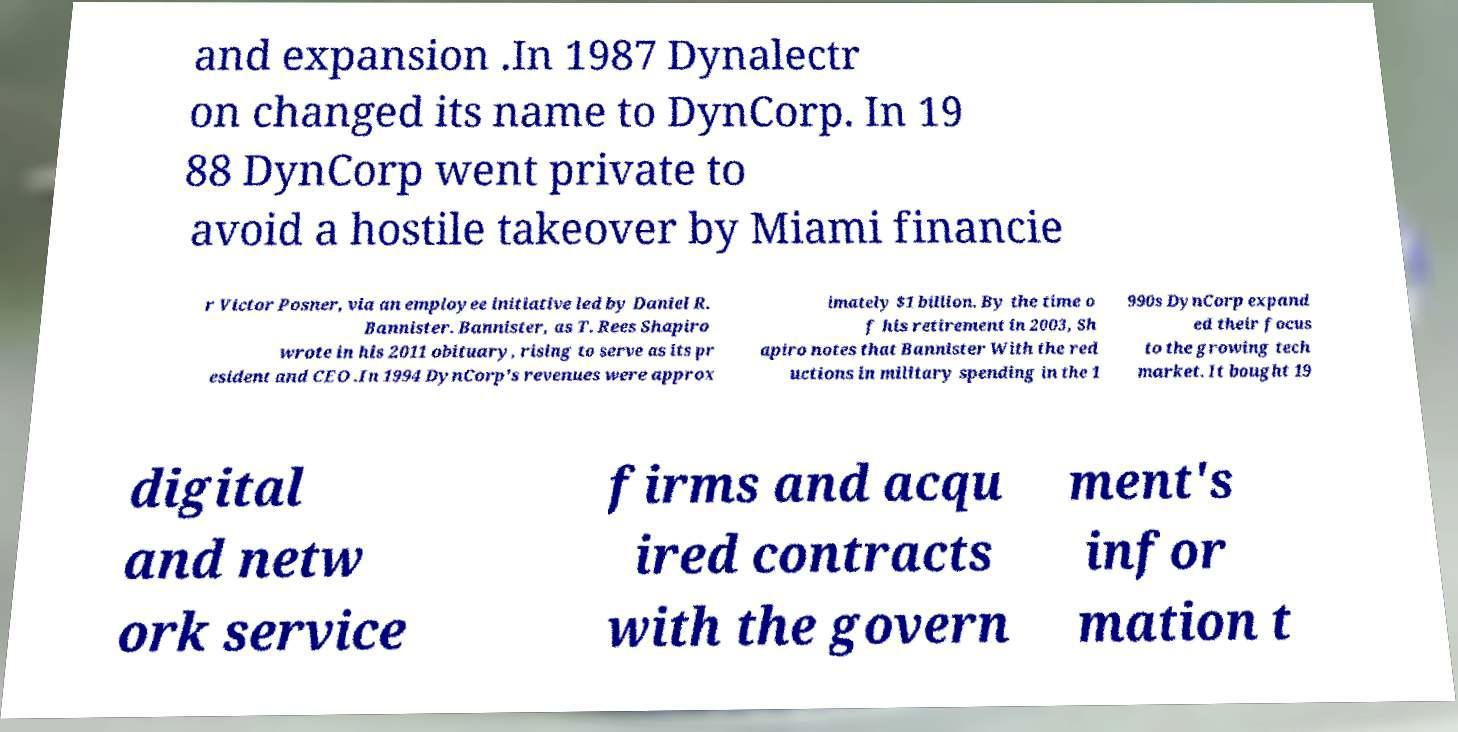For documentation purposes, I need the text within this image transcribed. Could you provide that? and expansion .In 1987 Dynalectr on changed its name to DynCorp. In 19 88 DynCorp went private to avoid a hostile takeover by Miami financie r Victor Posner, via an employee initiative led by Daniel R. Bannister. Bannister, as T. Rees Shapiro wrote in his 2011 obituary, rising to serve as its pr esident and CEO .In 1994 DynCorp's revenues were approx imately $1 billion. By the time o f his retirement in 2003, Sh apiro notes that Bannister With the red uctions in military spending in the 1 990s DynCorp expand ed their focus to the growing tech market. It bought 19 digital and netw ork service firms and acqu ired contracts with the govern ment's infor mation t 